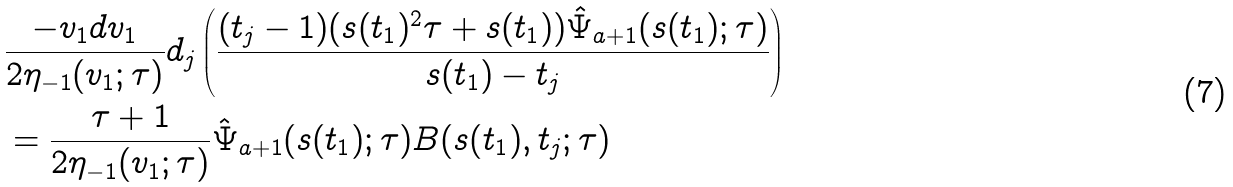Convert formula to latex. <formula><loc_0><loc_0><loc_500><loc_500>& \frac { - v _ { 1 } d v _ { 1 } } { 2 \eta _ { - 1 } ( v _ { 1 } ; \tau ) } d _ { j } \left ( \frac { ( t _ { j } - 1 ) ( s ( t _ { 1 } ) ^ { 2 } \tau + s ( t _ { 1 } ) ) \hat { \Psi } _ { a + 1 } ( s ( t _ { 1 } ) ; \tau ) } { s ( t _ { 1 } ) - t _ { j } } \right ) \\ & = \frac { \tau + 1 } { 2 \eta _ { - 1 } ( v _ { 1 } ; \tau ) } \hat { \Psi } _ { a + 1 } ( s ( t _ { 1 } ) ; \tau ) B ( s ( t _ { 1 } ) , t _ { j } ; \tau )</formula> 